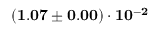Convert formula to latex. <formula><loc_0><loc_0><loc_500><loc_500>( 1 . 0 7 \pm 0 . 0 0 ) \cdot 1 0 ^ { - 2 }</formula> 